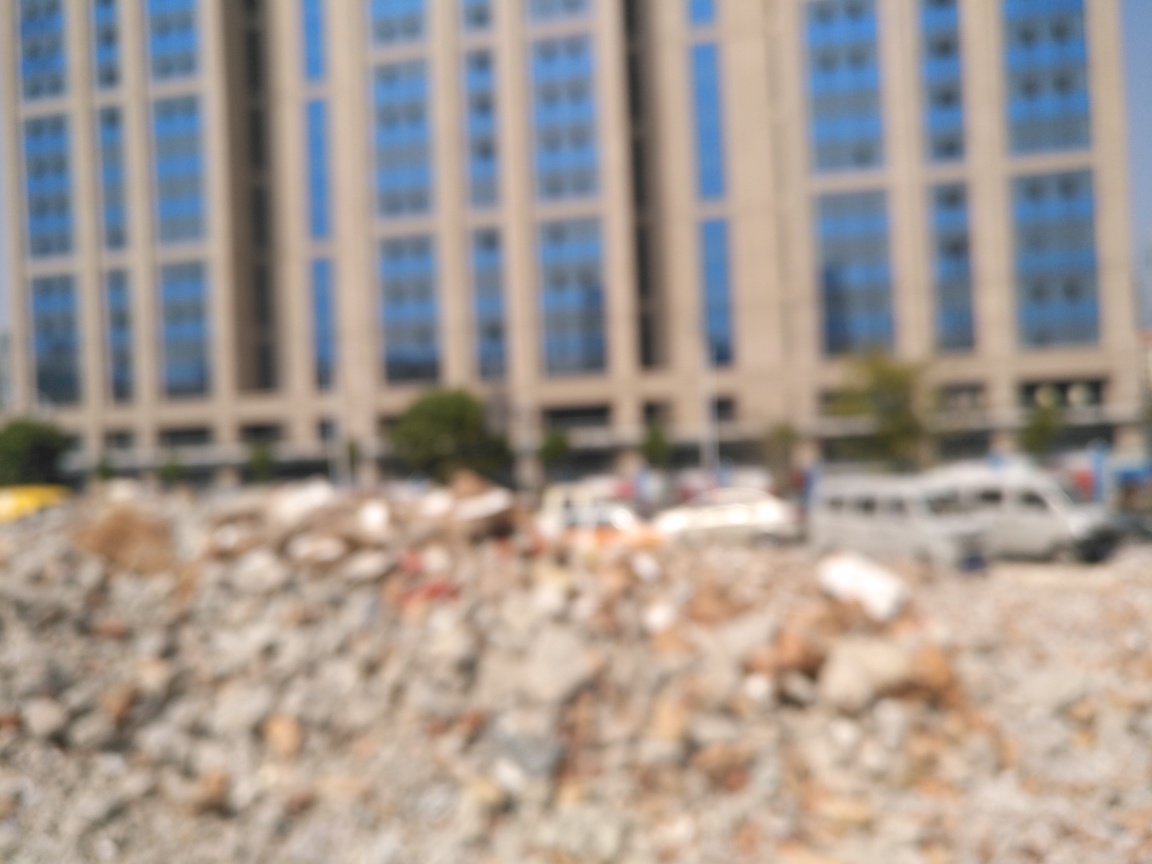Is the image clear? No, the image is not clear. It appears to be intentionally blurred, which obscures any details that might be present. The focus is not sharp, making it difficult to identify specific features or objects within the view. 